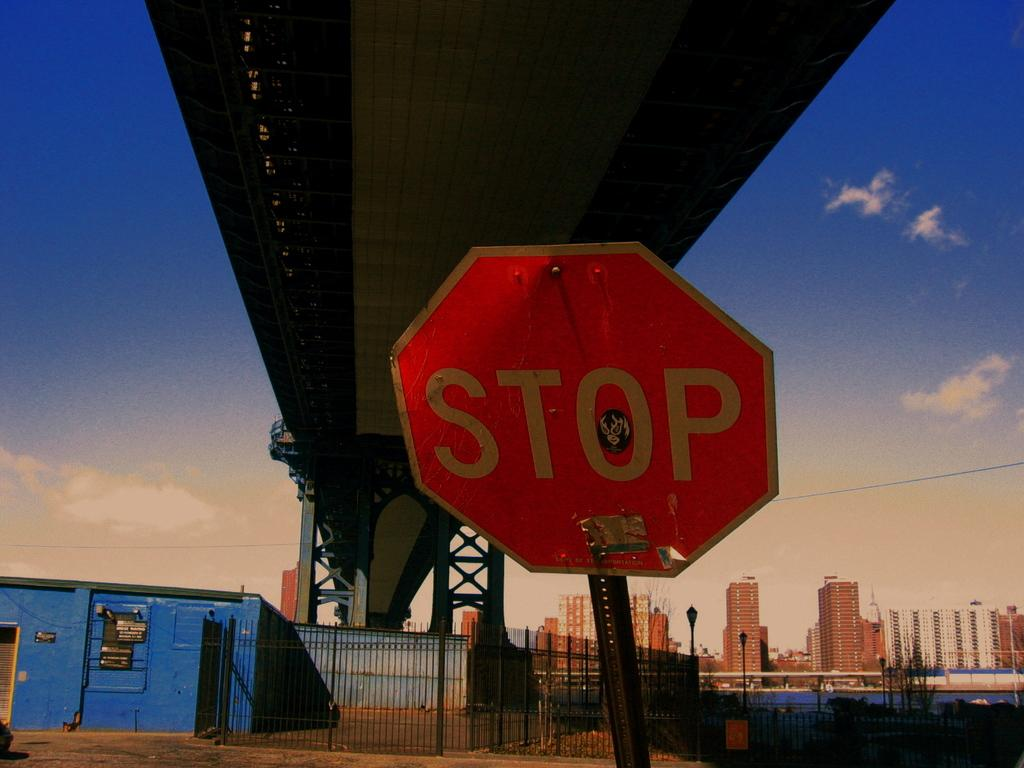<image>
Write a terse but informative summary of the picture. a red octogon stop sign near a blue building under a bridge 